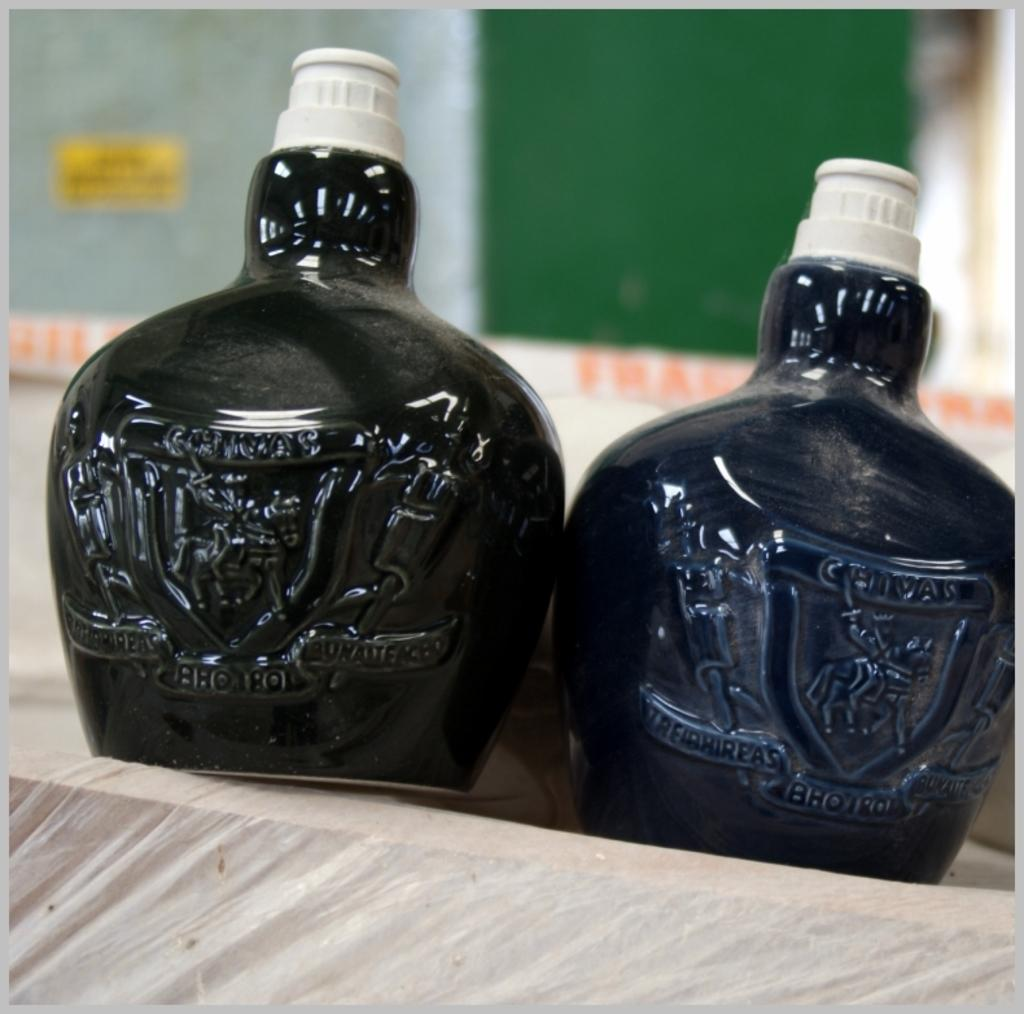<image>
Present a compact description of the photo's key features. Two fat bottles of Chivas are sitting side by side. 